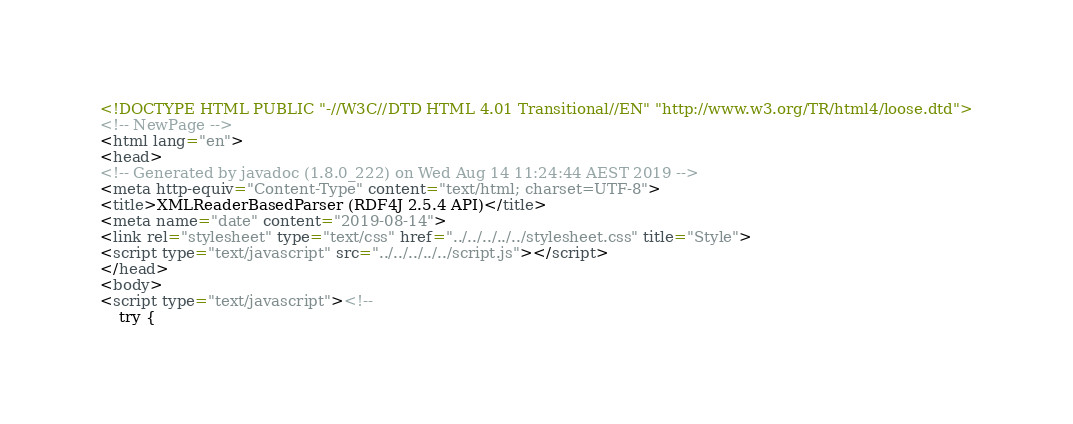<code> <loc_0><loc_0><loc_500><loc_500><_HTML_><!DOCTYPE HTML PUBLIC "-//W3C//DTD HTML 4.01 Transitional//EN" "http://www.w3.org/TR/html4/loose.dtd">
<!-- NewPage -->
<html lang="en">
<head>
<!-- Generated by javadoc (1.8.0_222) on Wed Aug 14 11:24:44 AEST 2019 -->
<meta http-equiv="Content-Type" content="text/html; charset=UTF-8">
<title>XMLReaderBasedParser (RDF4J 2.5.4 API)</title>
<meta name="date" content="2019-08-14">
<link rel="stylesheet" type="text/css" href="../../../../../stylesheet.css" title="Style">
<script type="text/javascript" src="../../../../../script.js"></script>
</head>
<body>
<script type="text/javascript"><!--
    try {</code> 